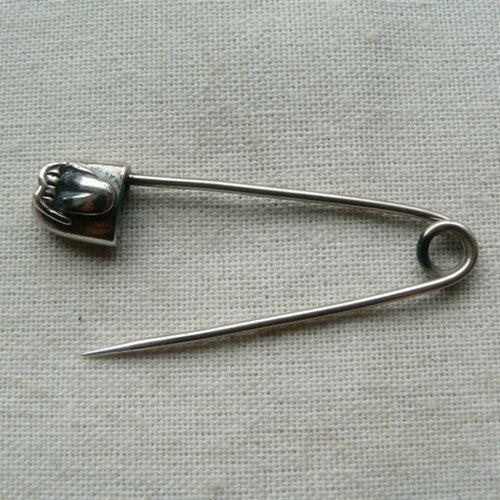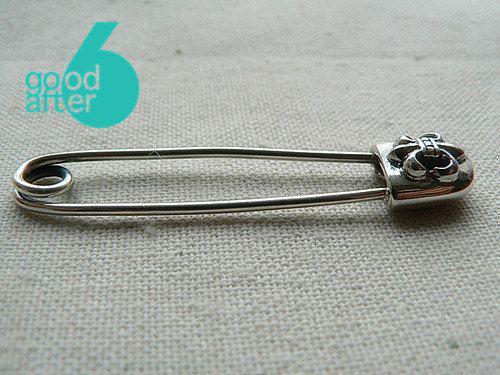The first image is the image on the left, the second image is the image on the right. Given the left and right images, does the statement "There are two safety pins" hold true? Answer yes or no. Yes. The first image is the image on the left, the second image is the image on the right. Assess this claim about the two images: "One safety pin is open and one is closed.". Correct or not? Answer yes or no. Yes. 